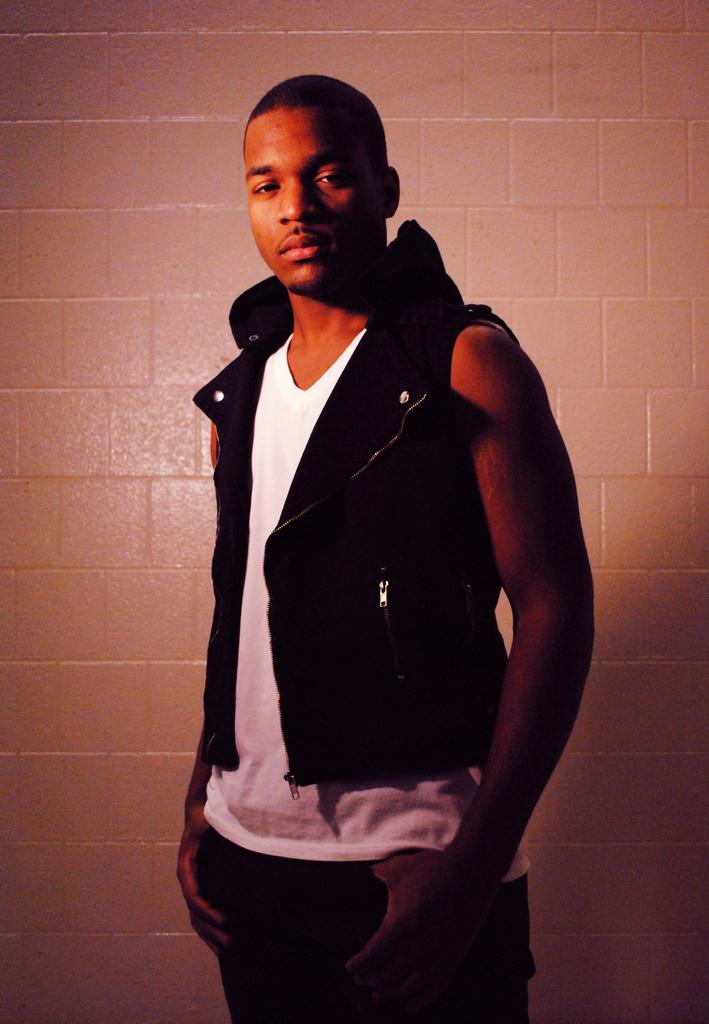Who is present in the image? There is a man in the image. What is the man doing in the image? The man is standing in front of a wall and posing for a photo. What is the man wearing in the image? The man is wearing a black jacket. How many frogs can be seen in the image? There are no frogs present in the image. What type of love is being expressed in the image? There is no expression of love in the image; it simply shows a man posing for a photo. 